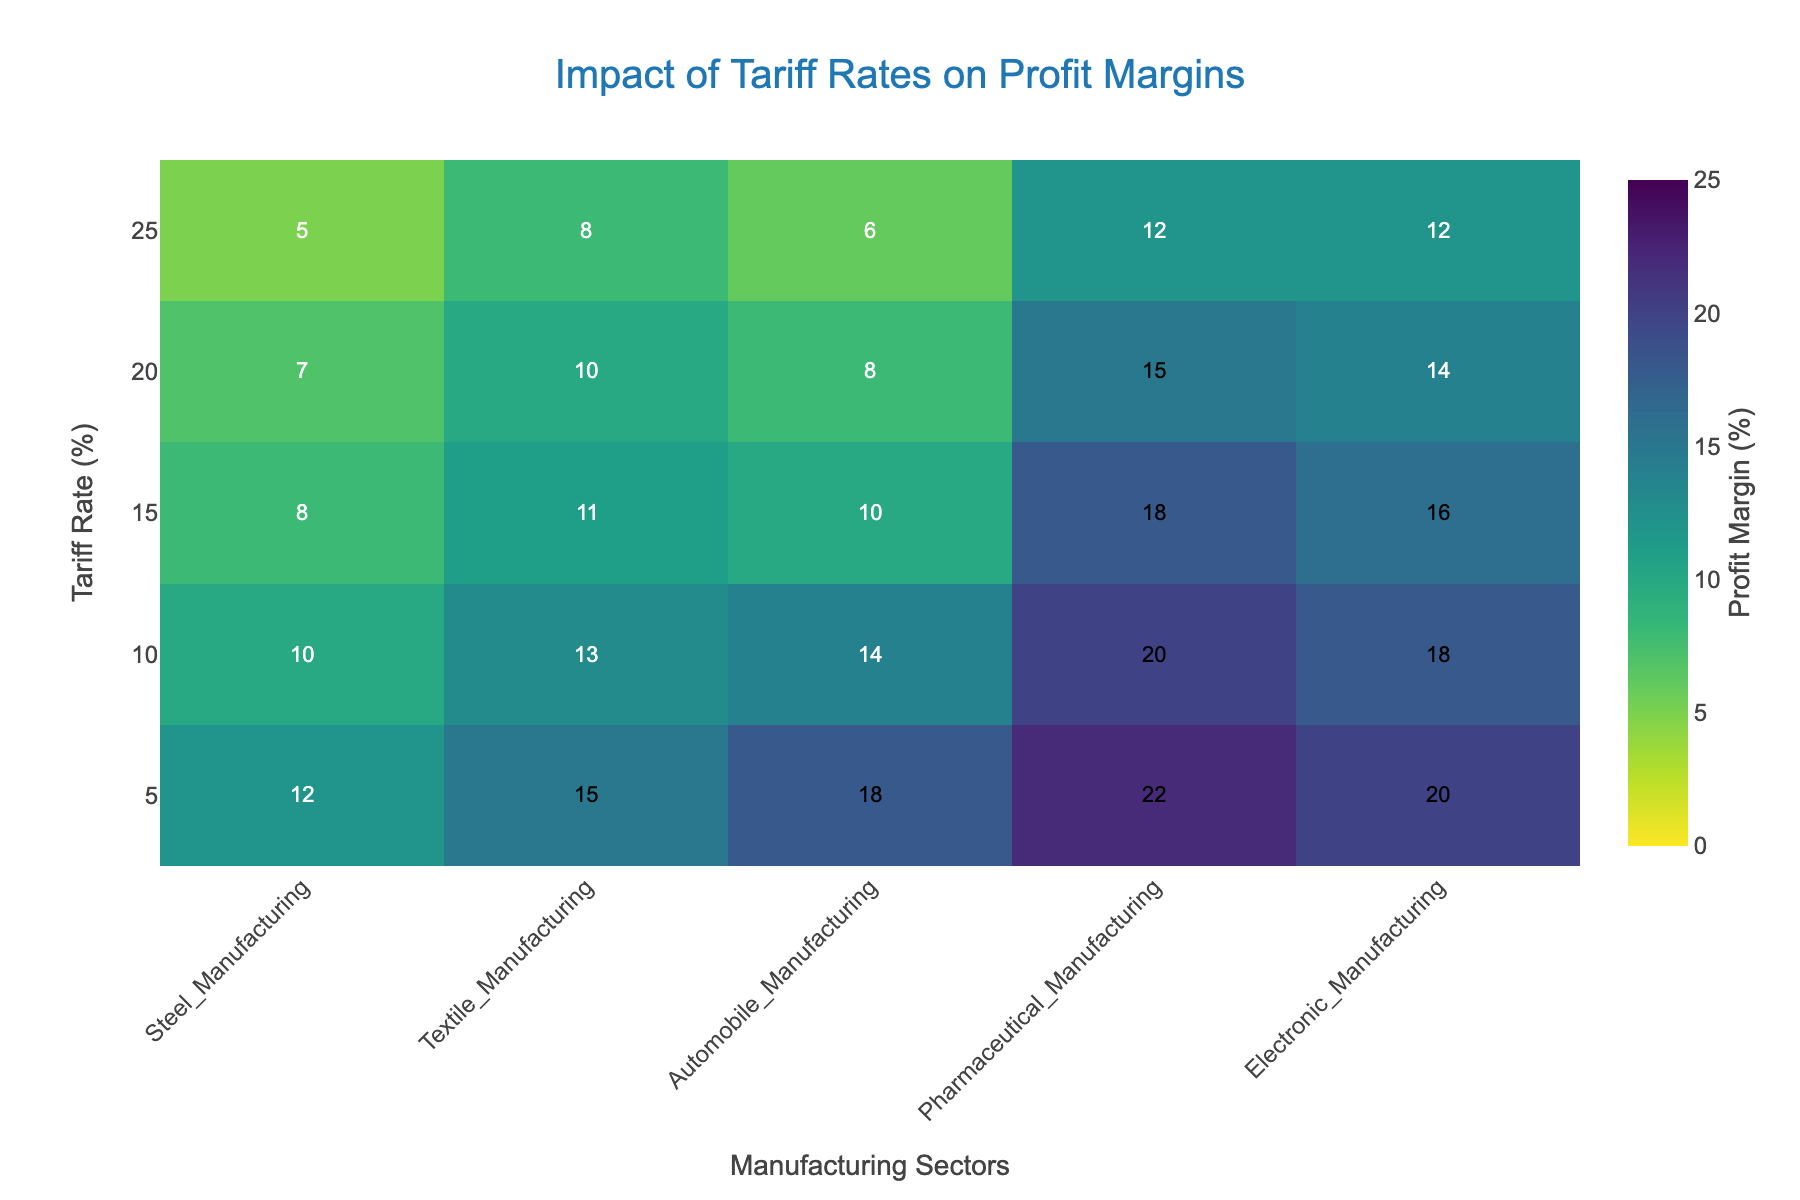What's the title of the heatmap? The title of the heatmap is located at the top and is "Impact of Tariff Rates on Profit Margins"
Answer: Impact of Tariff Rates on Profit Margins What does the color represent in this heatmap? The color represents the profit margins in percent across different domestic manufacturing firms, with the color intensity changing based on the profit margin values.
Answer: Profit margins (%) What is the profit margin for Steel Manufacturing at a 15% tariff rate? Locate the column for "Steel Manufacturing" and the row for a 15% tariff rate, which intersects at a profit margin of 8.
Answer: 8 At which tariff rate does Textile Manufacturing show the highest profit margin? Check the values in the "Textile Manufacturing" column to find that the highest profit margin is 15% at a 5% tariff rate.
Answer: 5% Which manufacturing sector shows the highest average profit margin across all tariff rates? Calculate the average profit margin for each sector by summing the profit margins and dividing by the number of tariff rates. Steel: (12+10+8+7+5)/5=8.4, Textile: (15+13+11+10+8)/5=11.4, Auto: (18+14+10+8+6)/5=11.2, Pharma: (22+20+18+15+12)/5=17.4, Electronic: (20+18+16+14+12)/5=16.0. The Pharmaceutical Manufacturing sector has the highest average of 17.4.
Answer: Pharmaceutical Manufacturing Compare the profit margins of Electronic Manufacturing and Automobile Manufacturing at a 10% tariff rate. Which one is higher? Compare the values: Electronic Manufacturing (18) vs. Automobile Manufacturing (14). Electronic Manufacturing has a higher profit margin.
Answer: Electronic Manufacturing What is the sum of profit margins for the Pharmaceutical Manufacturing sector at all tariff rates? Sum the profit margins for the Pharmaceutical Manufacturing sector: 22 + 20 + 18 + 15 + 12 = 87.
Answer: 87 What is the median profit margin for Steel Manufacturing across all tariff rates? Organize the profit margins of Steel Manufacturing: 5, 7, 8, 10, 12. The median is the middle value, which is 8.
Answer: 8 Which sector shows a decreasing trend in profit margins as the tariff rate increases? Observe each column: Steel Manufacturing (yes), Textile Manufacturing (yes), Automobile Manufacturing (yes), Pharmaceutical Manufacturing (yes), Electronic Manufacturing (yes). All sectors show a decreasing trend.
Answer: All sectors How do the profit margins compare between the highest and lowest tariff rates for Textile Manufacturing? Compare values for Textile Manufacturing at a 5% tariff rate (15) and a 25% tariff rate (8). The profit margin decreased by 7.
Answer: Decreased by 7 